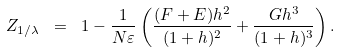<formula> <loc_0><loc_0><loc_500><loc_500>Z _ { 1 / \lambda } \ = \ 1 - \frac { 1 } { N \varepsilon } \left ( \frac { ( F + E ) h ^ { 2 } } { ( 1 + h ) ^ { 2 } } + \frac { G h ^ { 3 } } { ( 1 + h ) ^ { 3 } } \right ) .</formula> 